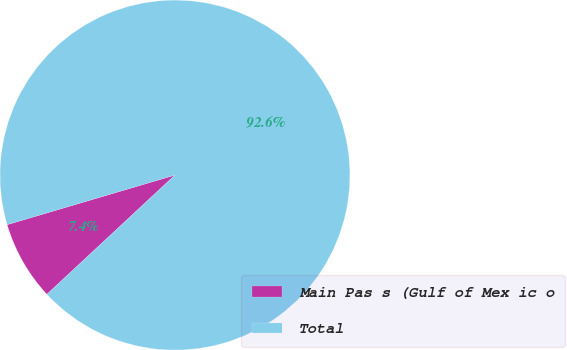Convert chart. <chart><loc_0><loc_0><loc_500><loc_500><pie_chart><fcel>Main Pas s (Gulf of Mex ic o<fcel>Total<nl><fcel>7.36%<fcel>92.64%<nl></chart> 